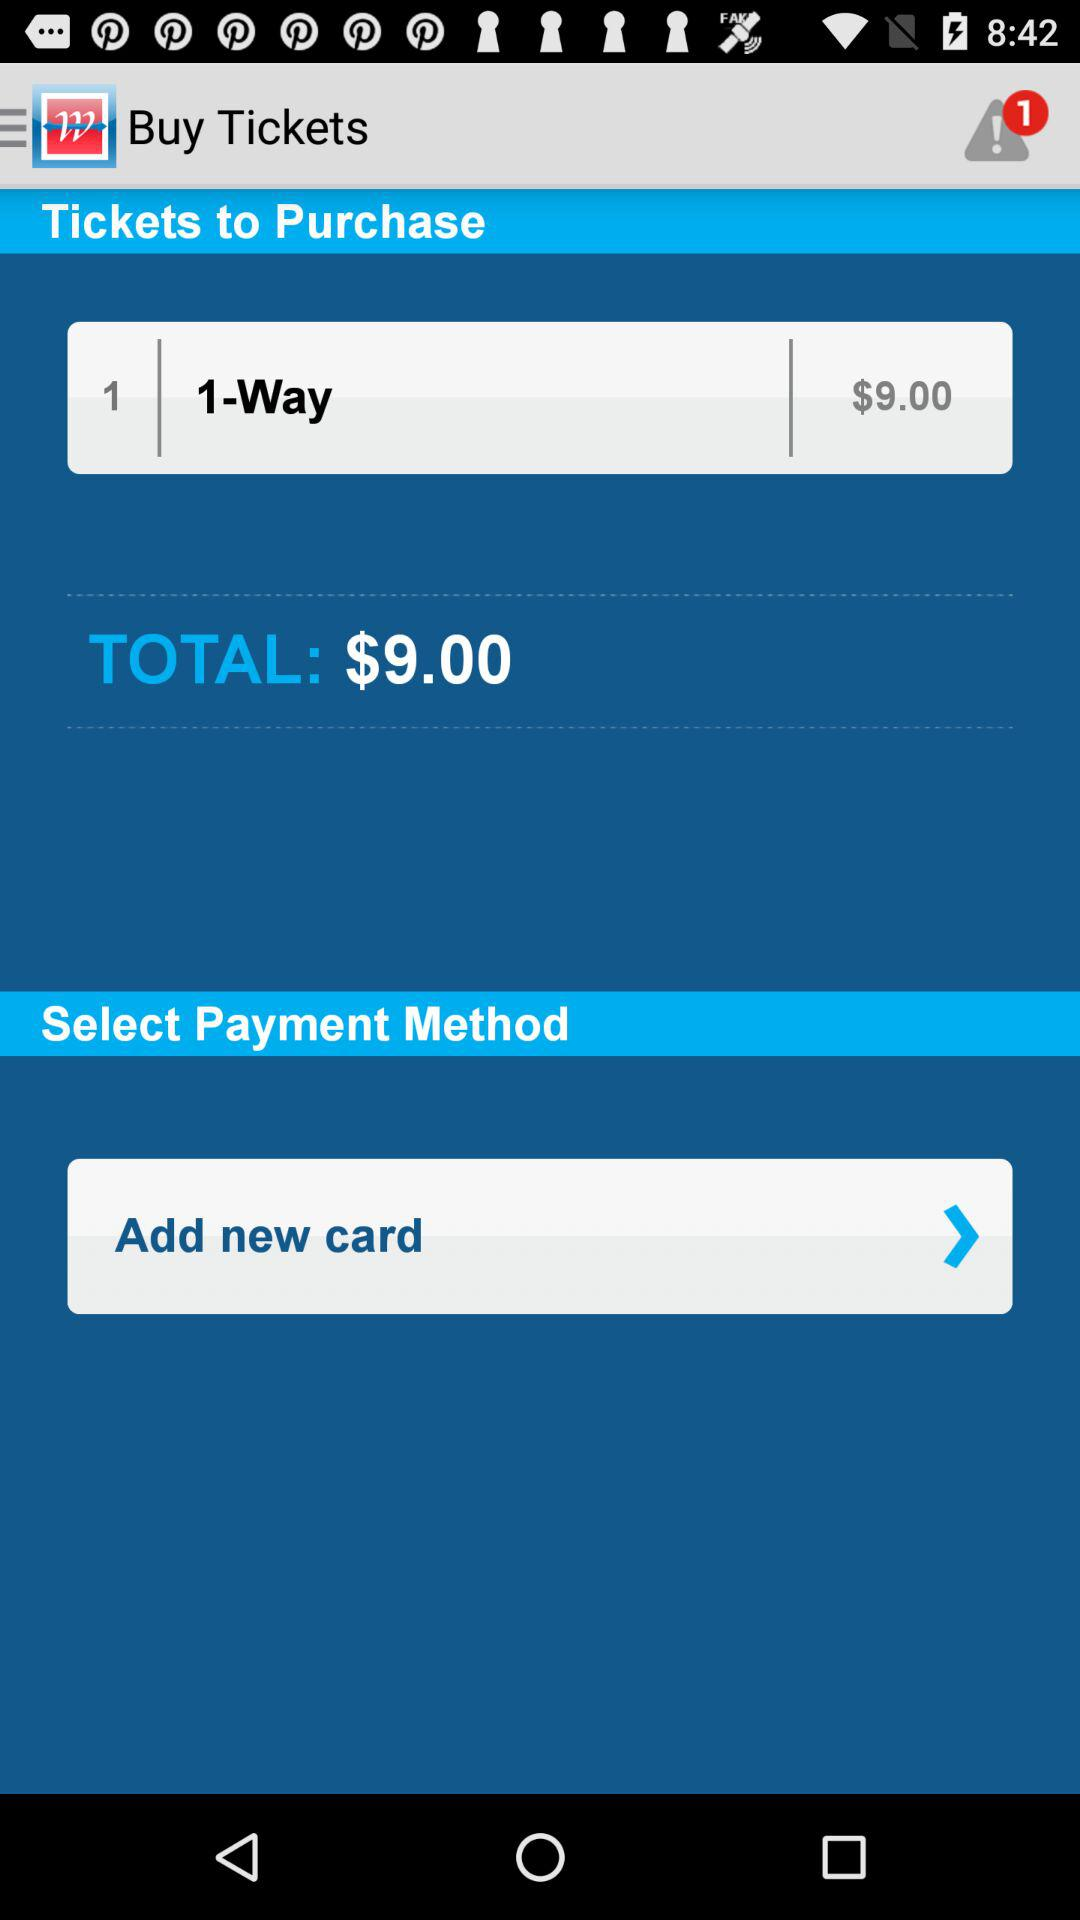What is the count of alert notifications? The count is 1. 